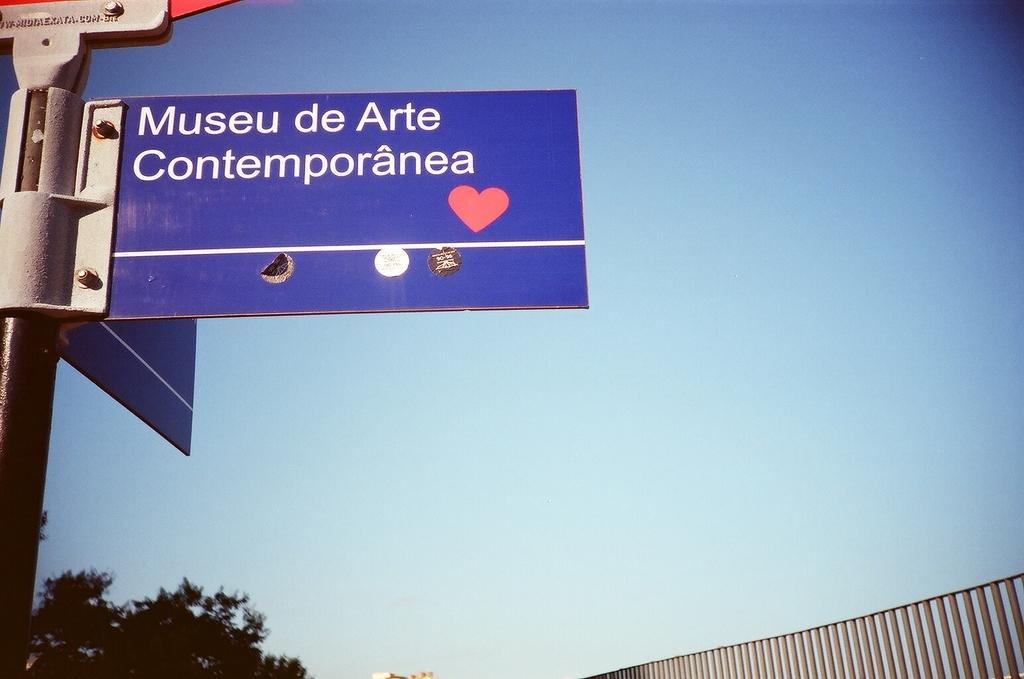<image>
Provide a brief description of the given image. A sign for the Museu de Arte Contemporânea. 